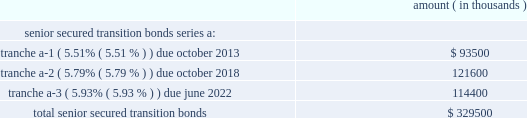Entergy corporation and subsidiaries notes to financial statements entergy new orleans securitization bonds - hurricane isaac in may 2015 the city council issued a financing order authorizing the issuance of securitization bonds to recover entergy new orleans 2019s hurricane isaac storm restoration costs of $ 31.8 million , including carrying costs , the costs of funding and replenishing the storm recovery reserve in the amount of $ 63.9 million , and approximately $ 3 million of up-front financing costs associated with the securitization .
In july 2015 , entergy new orleans storm recovery funding i , l.l.c. , a company wholly owned and consolidated by entergy new orleans , issued $ 98.7 million of storm cost recovery bonds .
The bonds have a coupon of 2.67% ( 2.67 % ) and an expected maturity date of june 2024 .
Although the principal amount is not due until the date given above , entergy new orleans storm recovery funding expects to make principal payments on the bonds over the next five years in the amounts of $ 11.4 million for 2016 , $ 10.6 million for 2017 , $ 11 million for 2018 , $ 11.2 million for 2019 , and $ 11.6 million for 2020 .
With the proceeds , entergy new orleans storm recovery funding purchased from entergy new orleans the storm recovery property , which is the right to recover from customers through a storm recovery charge amounts sufficient to service the securitization bonds .
The storm recovery property is reflected as a regulatory asset on the consolidated entergy new orleans balance sheet .
The creditors of entergy new orleans do not have recourse to the assets or revenues of entergy new orleans storm recovery funding , including the storm recovery property , and the creditors of entergy new orleans storm recovery funding do not have recourse to the assets or revenues of entergy new orleans .
Entergy new orleans has no payment obligations to entergy new orleans storm recovery funding except to remit storm recovery charge collections .
Entergy texas securitization bonds - hurricane rita in april 2007 the puct issued a financing order authorizing the issuance of securitization bonds to recover $ 353 million of entergy texas 2019s hurricane rita reconstruction costs and up to $ 6 million of transaction costs , offset by $ 32 million of related deferred income tax benefits .
In june 2007 , entergy gulf states reconstruction funding i , llc , a company that is now wholly-owned and consolidated by entergy texas , issued $ 329.5 million of senior secured transition bonds ( securitization bonds ) as follows : amount ( in thousands ) .
Although the principal amount of each tranche is not due until the dates given above , entergy gulf states reconstruction funding expects to make principal payments on the bonds over the next five years in the amounts of $ 26 million for 2016 , $ 27.6 million for 2017 , $ 29.2 million for 2018 , $ 30.9 million for 2019 , and $ 32.8 million for 2020 .
All of the scheduled principal payments for 2016 are for tranche a-2 , $ 23.6 million of the scheduled principal payments for 2017 are for tranche a-2 and $ 4 million of the scheduled principal payments for 2017 are for tranche a-3 .
All of the scheduled principal payments for 2018-2020 are for tranche a-3 .
With the proceeds , entergy gulf states reconstruction funding purchased from entergy texas the transition property , which is the right to recover from customers through a transition charge amounts sufficient to service the securitization bonds .
The transition property is reflected as a regulatory asset on the consolidated entergy texas balance sheet .
The creditors of entergy texas do not have recourse to the assets or revenues of entergy gulf states reconstruction funding , including the transition property , and the creditors of entergy gulf states reconstruction funding do not have recourse to the assets or revenues of entergy texas .
Entergy texas has no payment obligations to entergy gulf states reconstruction funding except to remit transition charge collections. .
In 2007 what was the percent of the total senior secured transition bonds by entergy texas that was tranche a-2 due october 2018? 
Computations: (121600 / 329500)
Answer: 0.36904. 